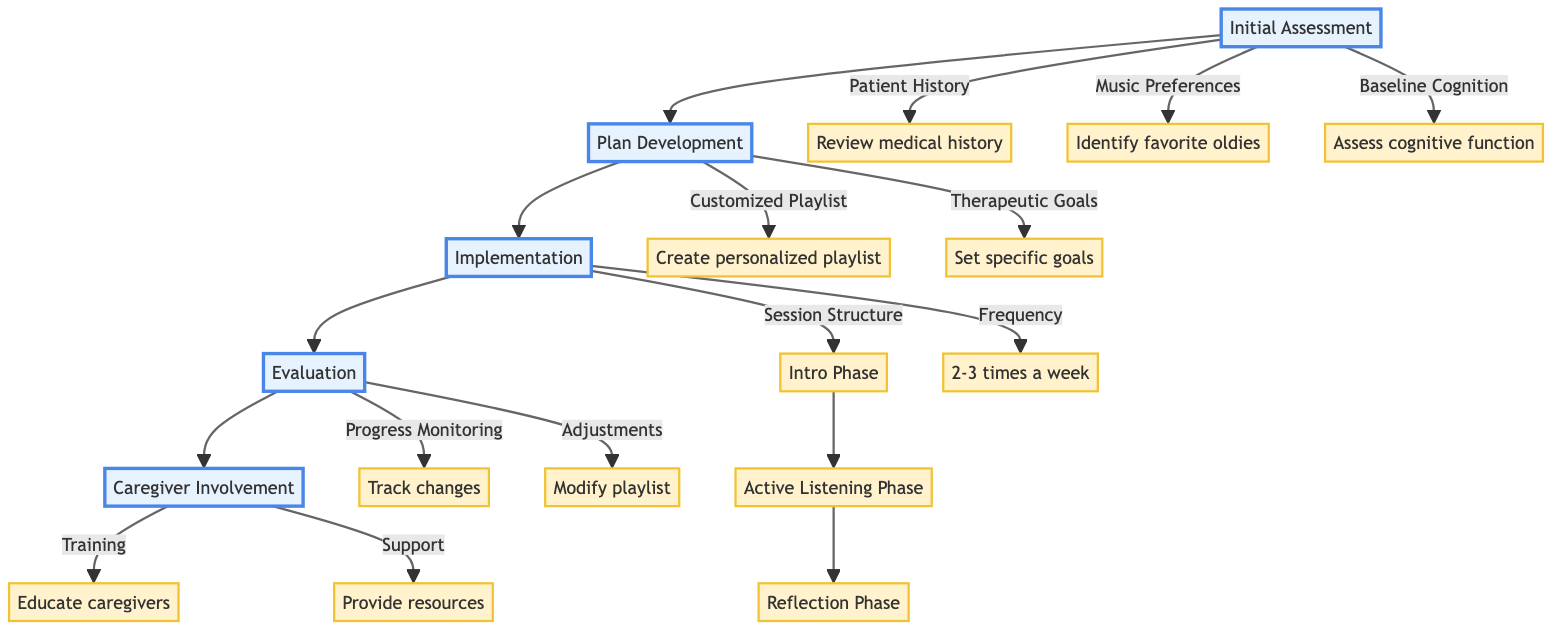What are the main phases in the clinical pathway? The diagram shows five main phases connected sequentially: Initial Assessment, Plan Development, Implementation, Evaluation, and Caregiver Involvement. These phases outline the structure of the clinical pathway for music therapy plans for dementia patients.
Answer: Initial Assessment, Plan Development, Implementation, Evaluation, Caregiver Involvement How many subphases are under Implementation? Under the Implementation phase, there are two subphases: Session Structure and Frequency. The Session Structure is further divided into Intro Phase, Active Listening Phase, and Reflection Phase, totaling four subphases in this section.
Answer: Four What is the purpose of the Initial Assessment phase? The purpose of the Initial Assessment is to gather comprehensive information about the patient, including their medical history, music preferences, and cognitive baseline. This foundational information is critical for developing an effective therapy plan tailored to the patient's needs.
Answer: Gather patient information How often should the music therapy sessions be scheduled? The diagram specifies that music therapy sessions should be scheduled 2-3 times a week, providing a clear frequency guideline for implementation. This regularity aims to enhance the therapeutic effect and support the patient’s needs.
Answer: 2-3 times a week What is synthesized from the Evaluation phase in the clinical pathway? In the Evaluation phase, the progress monitoring involves tracking cognitive and emotional changes through various methods, including self-reports and caregiver observations. The adjustments made based on feedback and observed outcomes are synthesized here, ultimately leading to improved music therapy sessions.
Answer: Progress monitoring and adjustments What is a key component of Caregiver Involvement? A key component of Caregiver Involvement is training caregivers on the importance of music therapy and best practices for facilitating sessions. This education empowers caregivers to support the patient's therapy effectively, ensuring continuity and enhanced outcomes at home.
Answer: Training caregivers Which artists are suggested for the customized playlist? The diagram indicates that the personalized playlist should include artists like Elvis Presley, The Beatles, and Frank Sinatra. These artists are chosen based on their popularity and emotional connection to many elderly patients, enhancing reminiscence and engagement during sessions.
Answer: Elvis Presley, The Beatles, Frank Sinatra What triggers the Reflection Phase in the session structure? The Reflection Phase is triggered at the conclusion of the music therapy session, where participants engage in discussions about their emotions and memories that were stimulated by the music played during the Active Listening Phase. This element encourages cognitive engagement and emotional resonance.
Answer: Discussion about emotions and memories What is the goal of setting therapeutic goals in the Plan Development phase? The goal of establishing therapeutic goals in the Plan Development phase is to define clear, measurable objectives for the music therapy sessions, such as reducing agitation, improving mood, and enhancing memory recall. These goals serve to guide the therapy and evaluate effectiveness over time.
Answer: Define clear objectives for therapy 